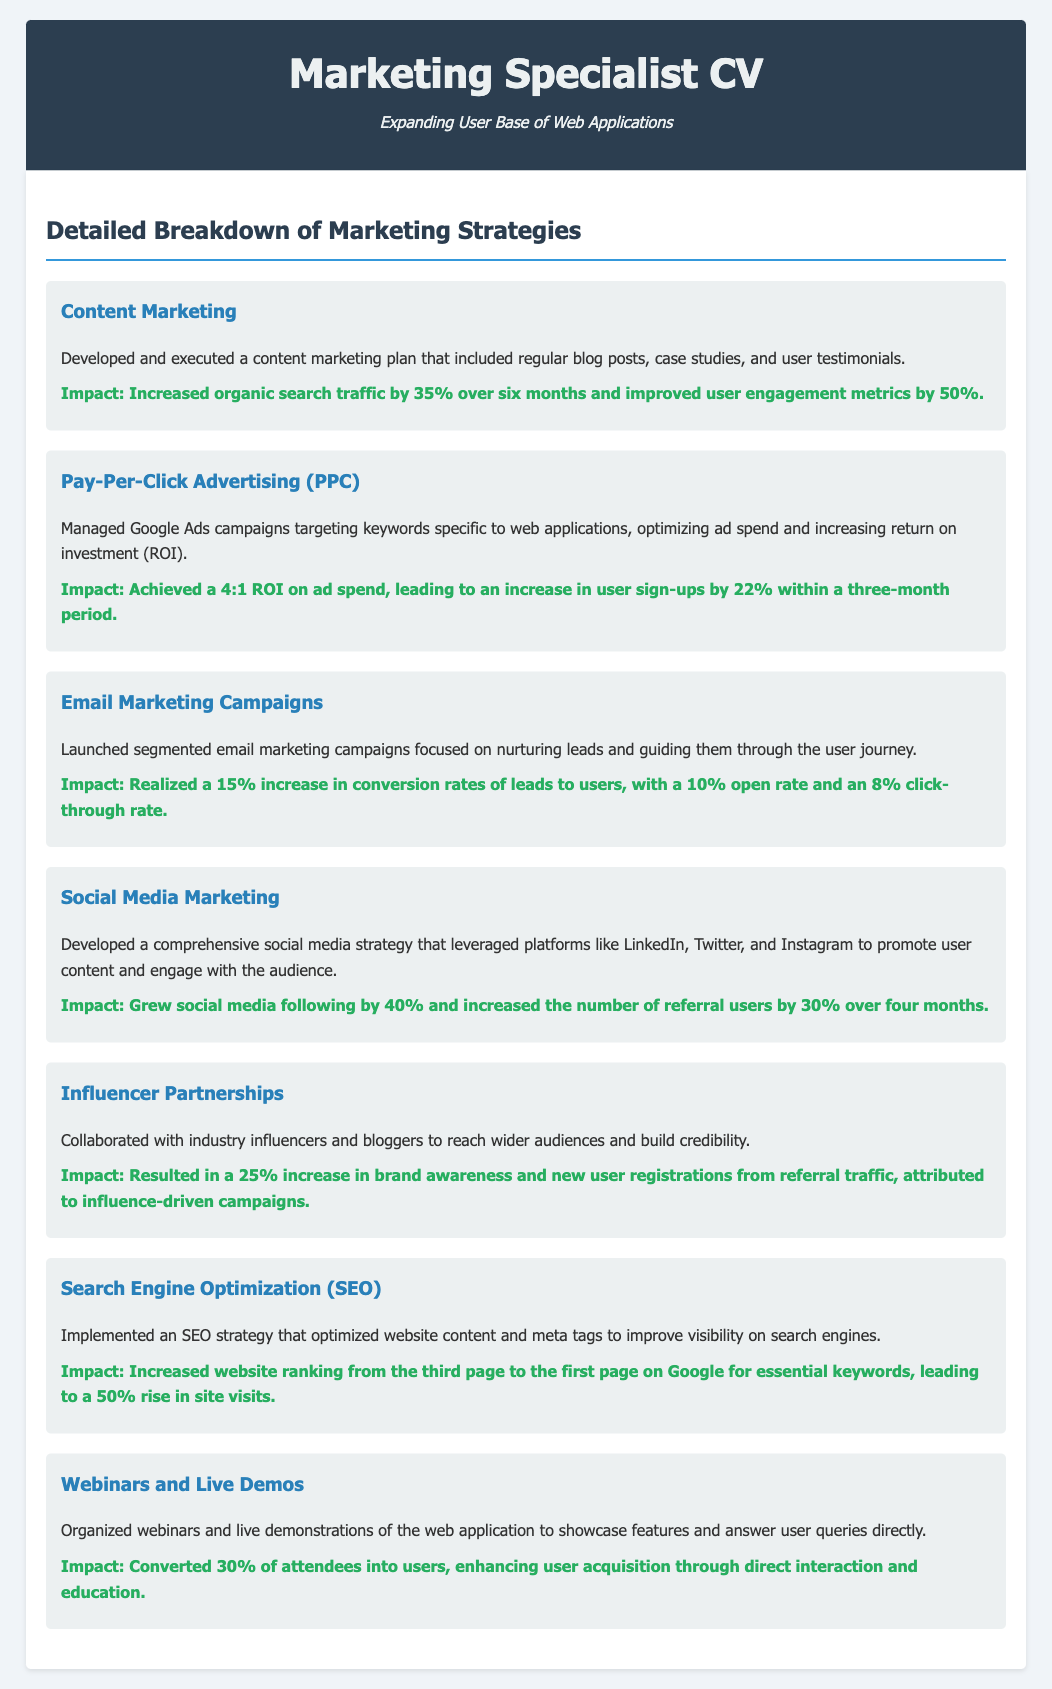What marketing strategy increased organic search traffic by 35%? The document states that the content marketing strategy led to a 35% increase in organic search traffic.
Answer: Content Marketing What was the ROI achieved through the PPC campaign? The PPC campaign provided a 4:1 return on investment, according to the information presented.
Answer: 4:1 By what percentage did social media following grow? The document mentions a 40% growth in social media following as part of the social media marketing strategy.
Answer: 40% How much did email marketing campaigns increase conversion rates? Email marketing campaigns resulted in a 15% increase in conversion rates of leads to users, as highlighted in the document.
Answer: 15% What was the impact of webinars on user conversion? The document indicates that 30% of attendees were converted into users through the webinars and live demos.
Answer: 30% Which strategy improved website ranking from the third page to the first page? The search engine optimization (SEO) strategy is noted for improving website ranking significantly in the document.
Answer: Search Engine Optimization What strategy resulted in a 25% increase in brand awareness? The document specifies that influencer partnerships led to a 25% increase in brand awareness.
Answer: Influencer Partnerships What percentage of user sign-ups increased due to PPC advertising? The impact of PPC advertising on user sign-ups is documented as a 22% increase.
Answer: 22% 